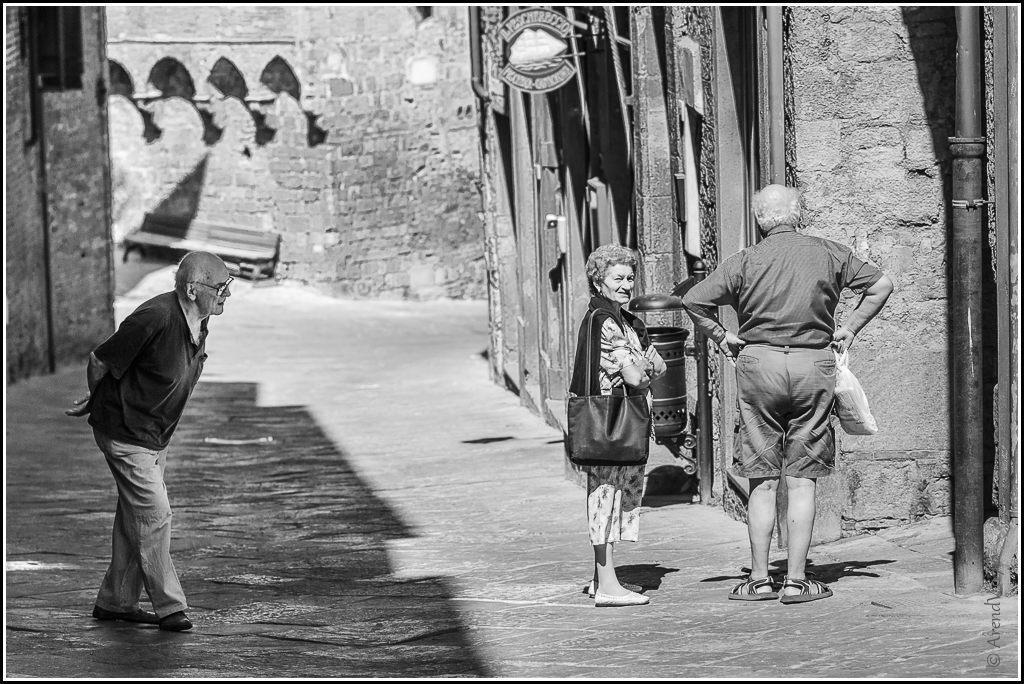Please provide a concise description of this image. This is a black and white image in which we can see some people standing on the ground. In that a man is holding a bag. We can also see some poles, walls, a sign board and a bench. 